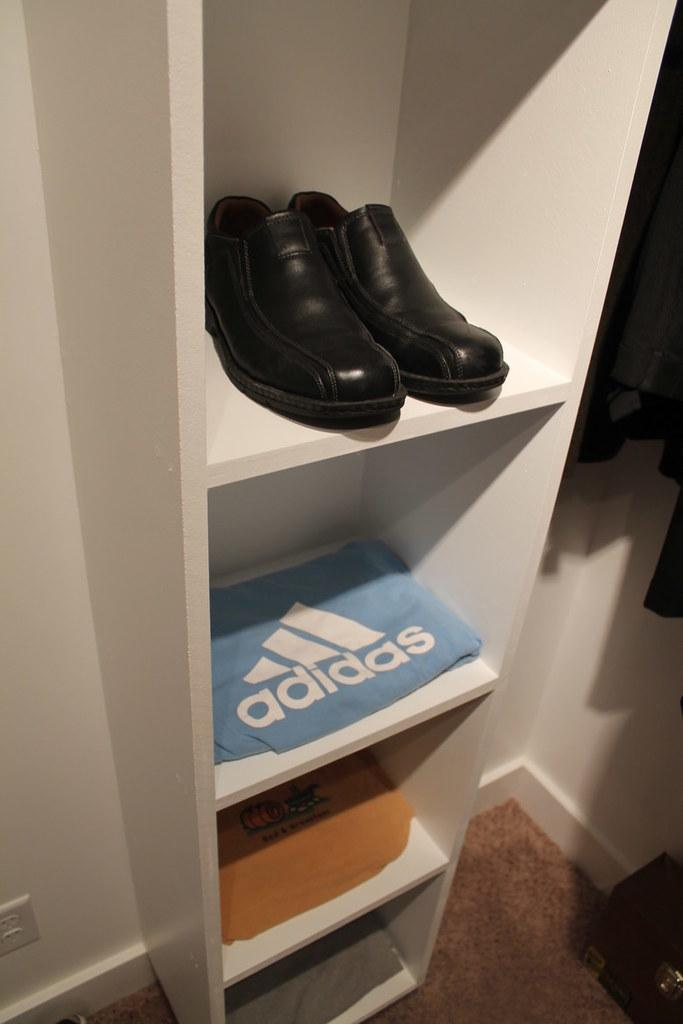What can be seen on the shelf in the image? There is a pair of shoes and papers on the shelf in the image. What type of flooring is visible in the image? There is a carpet on the floor in the image. What else can be seen on the side of the image? There are clothes on the side of the image. How many loaves of bread can be seen on the shelf in the image? There is no bread present on the shelf in the image. What type of crack is visible on the carpet in the image? There is no crack visible on the carpet in the image. 